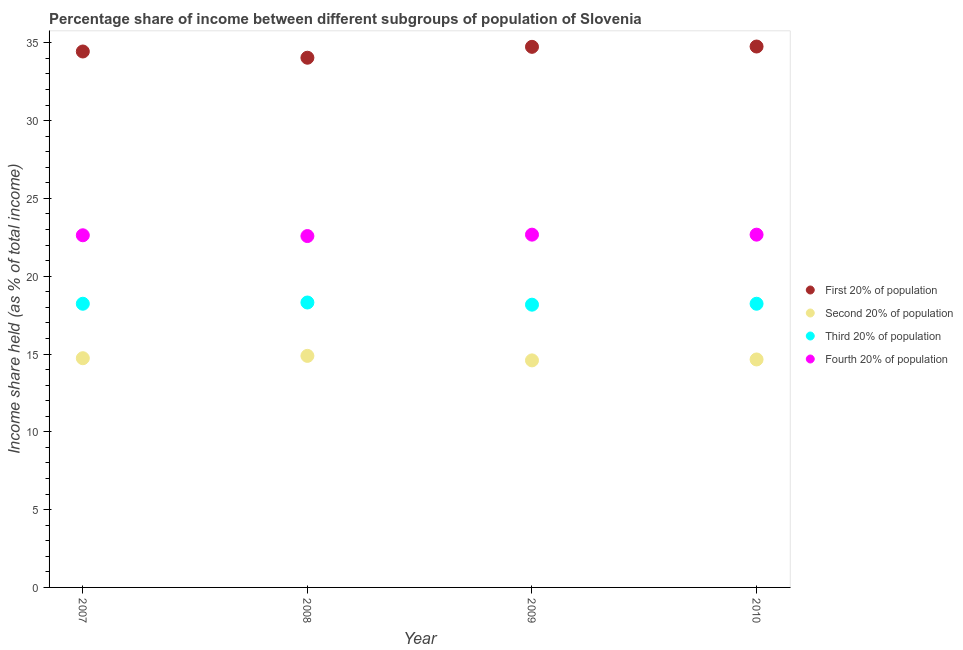What is the share of the income held by second 20% of the population in 2010?
Give a very brief answer. 14.65. Across all years, what is the maximum share of the income held by first 20% of the population?
Ensure brevity in your answer.  34.76. Across all years, what is the minimum share of the income held by fourth 20% of the population?
Ensure brevity in your answer.  22.58. In which year was the share of the income held by fourth 20% of the population maximum?
Provide a short and direct response. 2009. What is the total share of the income held by third 20% of the population in the graph?
Provide a short and direct response. 72.94. What is the difference between the share of the income held by third 20% of the population in 2007 and that in 2008?
Give a very brief answer. -0.08. What is the difference between the share of the income held by first 20% of the population in 2007 and the share of the income held by second 20% of the population in 2010?
Provide a short and direct response. 19.79. What is the average share of the income held by second 20% of the population per year?
Offer a terse response. 14.71. What is the ratio of the share of the income held by second 20% of the population in 2008 to that in 2010?
Keep it short and to the point. 1.02. Is the difference between the share of the income held by first 20% of the population in 2007 and 2010 greater than the difference between the share of the income held by fourth 20% of the population in 2007 and 2010?
Give a very brief answer. No. What is the difference between the highest and the second highest share of the income held by first 20% of the population?
Make the answer very short. 0.02. What is the difference between the highest and the lowest share of the income held by fourth 20% of the population?
Offer a terse response. 0.09. Is the sum of the share of the income held by third 20% of the population in 2009 and 2010 greater than the maximum share of the income held by fourth 20% of the population across all years?
Offer a terse response. Yes. Is it the case that in every year, the sum of the share of the income held by first 20% of the population and share of the income held by third 20% of the population is greater than the sum of share of the income held by fourth 20% of the population and share of the income held by second 20% of the population?
Your answer should be very brief. Yes. Is it the case that in every year, the sum of the share of the income held by first 20% of the population and share of the income held by second 20% of the population is greater than the share of the income held by third 20% of the population?
Provide a short and direct response. Yes. Is the share of the income held by third 20% of the population strictly greater than the share of the income held by first 20% of the population over the years?
Your answer should be very brief. No. Is the share of the income held by third 20% of the population strictly less than the share of the income held by fourth 20% of the population over the years?
Keep it short and to the point. Yes. How many years are there in the graph?
Provide a succinct answer. 4. What is the difference between two consecutive major ticks on the Y-axis?
Your answer should be very brief. 5. Are the values on the major ticks of Y-axis written in scientific E-notation?
Give a very brief answer. No. Does the graph contain any zero values?
Offer a very short reply. No. How many legend labels are there?
Your answer should be compact. 4. What is the title of the graph?
Provide a short and direct response. Percentage share of income between different subgroups of population of Slovenia. Does "Social Insurance" appear as one of the legend labels in the graph?
Keep it short and to the point. No. What is the label or title of the Y-axis?
Your answer should be very brief. Income share held (as % of total income). What is the Income share held (as % of total income) of First 20% of population in 2007?
Your response must be concise. 34.44. What is the Income share held (as % of total income) in Second 20% of population in 2007?
Your answer should be compact. 14.73. What is the Income share held (as % of total income) of Third 20% of population in 2007?
Ensure brevity in your answer.  18.23. What is the Income share held (as % of total income) in Fourth 20% of population in 2007?
Keep it short and to the point. 22.63. What is the Income share held (as % of total income) in First 20% of population in 2008?
Your answer should be compact. 34.04. What is the Income share held (as % of total income) of Second 20% of population in 2008?
Your answer should be compact. 14.88. What is the Income share held (as % of total income) of Third 20% of population in 2008?
Keep it short and to the point. 18.31. What is the Income share held (as % of total income) of Fourth 20% of population in 2008?
Offer a terse response. 22.58. What is the Income share held (as % of total income) of First 20% of population in 2009?
Your response must be concise. 34.74. What is the Income share held (as % of total income) in Second 20% of population in 2009?
Your response must be concise. 14.59. What is the Income share held (as % of total income) of Third 20% of population in 2009?
Make the answer very short. 18.17. What is the Income share held (as % of total income) of Fourth 20% of population in 2009?
Your answer should be compact. 22.67. What is the Income share held (as % of total income) of First 20% of population in 2010?
Ensure brevity in your answer.  34.76. What is the Income share held (as % of total income) in Second 20% of population in 2010?
Give a very brief answer. 14.65. What is the Income share held (as % of total income) in Third 20% of population in 2010?
Make the answer very short. 18.23. What is the Income share held (as % of total income) of Fourth 20% of population in 2010?
Offer a very short reply. 22.67. Across all years, what is the maximum Income share held (as % of total income) in First 20% of population?
Make the answer very short. 34.76. Across all years, what is the maximum Income share held (as % of total income) of Second 20% of population?
Offer a very short reply. 14.88. Across all years, what is the maximum Income share held (as % of total income) of Third 20% of population?
Ensure brevity in your answer.  18.31. Across all years, what is the maximum Income share held (as % of total income) in Fourth 20% of population?
Provide a short and direct response. 22.67. Across all years, what is the minimum Income share held (as % of total income) in First 20% of population?
Your answer should be very brief. 34.04. Across all years, what is the minimum Income share held (as % of total income) of Second 20% of population?
Ensure brevity in your answer.  14.59. Across all years, what is the minimum Income share held (as % of total income) of Third 20% of population?
Give a very brief answer. 18.17. Across all years, what is the minimum Income share held (as % of total income) of Fourth 20% of population?
Your answer should be compact. 22.58. What is the total Income share held (as % of total income) of First 20% of population in the graph?
Your answer should be very brief. 137.98. What is the total Income share held (as % of total income) in Second 20% of population in the graph?
Keep it short and to the point. 58.85. What is the total Income share held (as % of total income) in Third 20% of population in the graph?
Give a very brief answer. 72.94. What is the total Income share held (as % of total income) of Fourth 20% of population in the graph?
Offer a terse response. 90.55. What is the difference between the Income share held (as % of total income) in Third 20% of population in 2007 and that in 2008?
Offer a very short reply. -0.08. What is the difference between the Income share held (as % of total income) of Second 20% of population in 2007 and that in 2009?
Make the answer very short. 0.14. What is the difference between the Income share held (as % of total income) in Fourth 20% of population in 2007 and that in 2009?
Provide a succinct answer. -0.04. What is the difference between the Income share held (as % of total income) of First 20% of population in 2007 and that in 2010?
Ensure brevity in your answer.  -0.32. What is the difference between the Income share held (as % of total income) in Third 20% of population in 2007 and that in 2010?
Offer a terse response. 0. What is the difference between the Income share held (as % of total income) in Fourth 20% of population in 2007 and that in 2010?
Offer a very short reply. -0.04. What is the difference between the Income share held (as % of total income) in First 20% of population in 2008 and that in 2009?
Your response must be concise. -0.7. What is the difference between the Income share held (as % of total income) in Second 20% of population in 2008 and that in 2009?
Make the answer very short. 0.29. What is the difference between the Income share held (as % of total income) in Third 20% of population in 2008 and that in 2009?
Your answer should be very brief. 0.14. What is the difference between the Income share held (as % of total income) of Fourth 20% of population in 2008 and that in 2009?
Provide a succinct answer. -0.09. What is the difference between the Income share held (as % of total income) in First 20% of population in 2008 and that in 2010?
Offer a very short reply. -0.72. What is the difference between the Income share held (as % of total income) in Second 20% of population in 2008 and that in 2010?
Make the answer very short. 0.23. What is the difference between the Income share held (as % of total income) in Fourth 20% of population in 2008 and that in 2010?
Ensure brevity in your answer.  -0.09. What is the difference between the Income share held (as % of total income) in First 20% of population in 2009 and that in 2010?
Your response must be concise. -0.02. What is the difference between the Income share held (as % of total income) of Second 20% of population in 2009 and that in 2010?
Make the answer very short. -0.06. What is the difference between the Income share held (as % of total income) in Third 20% of population in 2009 and that in 2010?
Offer a terse response. -0.06. What is the difference between the Income share held (as % of total income) of First 20% of population in 2007 and the Income share held (as % of total income) of Second 20% of population in 2008?
Provide a succinct answer. 19.56. What is the difference between the Income share held (as % of total income) in First 20% of population in 2007 and the Income share held (as % of total income) in Third 20% of population in 2008?
Your response must be concise. 16.13. What is the difference between the Income share held (as % of total income) of First 20% of population in 2007 and the Income share held (as % of total income) of Fourth 20% of population in 2008?
Ensure brevity in your answer.  11.86. What is the difference between the Income share held (as % of total income) of Second 20% of population in 2007 and the Income share held (as % of total income) of Third 20% of population in 2008?
Offer a terse response. -3.58. What is the difference between the Income share held (as % of total income) of Second 20% of population in 2007 and the Income share held (as % of total income) of Fourth 20% of population in 2008?
Your answer should be very brief. -7.85. What is the difference between the Income share held (as % of total income) of Third 20% of population in 2007 and the Income share held (as % of total income) of Fourth 20% of population in 2008?
Offer a very short reply. -4.35. What is the difference between the Income share held (as % of total income) of First 20% of population in 2007 and the Income share held (as % of total income) of Second 20% of population in 2009?
Provide a succinct answer. 19.85. What is the difference between the Income share held (as % of total income) of First 20% of population in 2007 and the Income share held (as % of total income) of Third 20% of population in 2009?
Provide a short and direct response. 16.27. What is the difference between the Income share held (as % of total income) in First 20% of population in 2007 and the Income share held (as % of total income) in Fourth 20% of population in 2009?
Give a very brief answer. 11.77. What is the difference between the Income share held (as % of total income) of Second 20% of population in 2007 and the Income share held (as % of total income) of Third 20% of population in 2009?
Offer a terse response. -3.44. What is the difference between the Income share held (as % of total income) of Second 20% of population in 2007 and the Income share held (as % of total income) of Fourth 20% of population in 2009?
Ensure brevity in your answer.  -7.94. What is the difference between the Income share held (as % of total income) of Third 20% of population in 2007 and the Income share held (as % of total income) of Fourth 20% of population in 2009?
Make the answer very short. -4.44. What is the difference between the Income share held (as % of total income) in First 20% of population in 2007 and the Income share held (as % of total income) in Second 20% of population in 2010?
Your response must be concise. 19.79. What is the difference between the Income share held (as % of total income) in First 20% of population in 2007 and the Income share held (as % of total income) in Third 20% of population in 2010?
Your response must be concise. 16.21. What is the difference between the Income share held (as % of total income) in First 20% of population in 2007 and the Income share held (as % of total income) in Fourth 20% of population in 2010?
Keep it short and to the point. 11.77. What is the difference between the Income share held (as % of total income) of Second 20% of population in 2007 and the Income share held (as % of total income) of Third 20% of population in 2010?
Give a very brief answer. -3.5. What is the difference between the Income share held (as % of total income) in Second 20% of population in 2007 and the Income share held (as % of total income) in Fourth 20% of population in 2010?
Provide a short and direct response. -7.94. What is the difference between the Income share held (as % of total income) in Third 20% of population in 2007 and the Income share held (as % of total income) in Fourth 20% of population in 2010?
Provide a short and direct response. -4.44. What is the difference between the Income share held (as % of total income) in First 20% of population in 2008 and the Income share held (as % of total income) in Second 20% of population in 2009?
Your answer should be very brief. 19.45. What is the difference between the Income share held (as % of total income) in First 20% of population in 2008 and the Income share held (as % of total income) in Third 20% of population in 2009?
Provide a short and direct response. 15.87. What is the difference between the Income share held (as % of total income) of First 20% of population in 2008 and the Income share held (as % of total income) of Fourth 20% of population in 2009?
Ensure brevity in your answer.  11.37. What is the difference between the Income share held (as % of total income) of Second 20% of population in 2008 and the Income share held (as % of total income) of Third 20% of population in 2009?
Offer a very short reply. -3.29. What is the difference between the Income share held (as % of total income) of Second 20% of population in 2008 and the Income share held (as % of total income) of Fourth 20% of population in 2009?
Your response must be concise. -7.79. What is the difference between the Income share held (as % of total income) of Third 20% of population in 2008 and the Income share held (as % of total income) of Fourth 20% of population in 2009?
Your response must be concise. -4.36. What is the difference between the Income share held (as % of total income) of First 20% of population in 2008 and the Income share held (as % of total income) of Second 20% of population in 2010?
Offer a very short reply. 19.39. What is the difference between the Income share held (as % of total income) of First 20% of population in 2008 and the Income share held (as % of total income) of Third 20% of population in 2010?
Keep it short and to the point. 15.81. What is the difference between the Income share held (as % of total income) of First 20% of population in 2008 and the Income share held (as % of total income) of Fourth 20% of population in 2010?
Offer a terse response. 11.37. What is the difference between the Income share held (as % of total income) of Second 20% of population in 2008 and the Income share held (as % of total income) of Third 20% of population in 2010?
Keep it short and to the point. -3.35. What is the difference between the Income share held (as % of total income) in Second 20% of population in 2008 and the Income share held (as % of total income) in Fourth 20% of population in 2010?
Provide a succinct answer. -7.79. What is the difference between the Income share held (as % of total income) in Third 20% of population in 2008 and the Income share held (as % of total income) in Fourth 20% of population in 2010?
Offer a terse response. -4.36. What is the difference between the Income share held (as % of total income) of First 20% of population in 2009 and the Income share held (as % of total income) of Second 20% of population in 2010?
Your answer should be very brief. 20.09. What is the difference between the Income share held (as % of total income) of First 20% of population in 2009 and the Income share held (as % of total income) of Third 20% of population in 2010?
Your answer should be very brief. 16.51. What is the difference between the Income share held (as % of total income) in First 20% of population in 2009 and the Income share held (as % of total income) in Fourth 20% of population in 2010?
Give a very brief answer. 12.07. What is the difference between the Income share held (as % of total income) in Second 20% of population in 2009 and the Income share held (as % of total income) in Third 20% of population in 2010?
Provide a short and direct response. -3.64. What is the difference between the Income share held (as % of total income) in Second 20% of population in 2009 and the Income share held (as % of total income) in Fourth 20% of population in 2010?
Make the answer very short. -8.08. What is the average Income share held (as % of total income) of First 20% of population per year?
Your response must be concise. 34.49. What is the average Income share held (as % of total income) in Second 20% of population per year?
Your answer should be very brief. 14.71. What is the average Income share held (as % of total income) in Third 20% of population per year?
Ensure brevity in your answer.  18.23. What is the average Income share held (as % of total income) in Fourth 20% of population per year?
Ensure brevity in your answer.  22.64. In the year 2007, what is the difference between the Income share held (as % of total income) of First 20% of population and Income share held (as % of total income) of Second 20% of population?
Your response must be concise. 19.71. In the year 2007, what is the difference between the Income share held (as % of total income) of First 20% of population and Income share held (as % of total income) of Third 20% of population?
Your answer should be very brief. 16.21. In the year 2007, what is the difference between the Income share held (as % of total income) of First 20% of population and Income share held (as % of total income) of Fourth 20% of population?
Offer a very short reply. 11.81. In the year 2007, what is the difference between the Income share held (as % of total income) of Third 20% of population and Income share held (as % of total income) of Fourth 20% of population?
Offer a terse response. -4.4. In the year 2008, what is the difference between the Income share held (as % of total income) of First 20% of population and Income share held (as % of total income) of Second 20% of population?
Make the answer very short. 19.16. In the year 2008, what is the difference between the Income share held (as % of total income) of First 20% of population and Income share held (as % of total income) of Third 20% of population?
Your answer should be very brief. 15.73. In the year 2008, what is the difference between the Income share held (as % of total income) in First 20% of population and Income share held (as % of total income) in Fourth 20% of population?
Give a very brief answer. 11.46. In the year 2008, what is the difference between the Income share held (as % of total income) in Second 20% of population and Income share held (as % of total income) in Third 20% of population?
Your answer should be very brief. -3.43. In the year 2008, what is the difference between the Income share held (as % of total income) in Second 20% of population and Income share held (as % of total income) in Fourth 20% of population?
Your answer should be very brief. -7.7. In the year 2008, what is the difference between the Income share held (as % of total income) in Third 20% of population and Income share held (as % of total income) in Fourth 20% of population?
Make the answer very short. -4.27. In the year 2009, what is the difference between the Income share held (as % of total income) in First 20% of population and Income share held (as % of total income) in Second 20% of population?
Ensure brevity in your answer.  20.15. In the year 2009, what is the difference between the Income share held (as % of total income) of First 20% of population and Income share held (as % of total income) of Third 20% of population?
Offer a terse response. 16.57. In the year 2009, what is the difference between the Income share held (as % of total income) in First 20% of population and Income share held (as % of total income) in Fourth 20% of population?
Make the answer very short. 12.07. In the year 2009, what is the difference between the Income share held (as % of total income) in Second 20% of population and Income share held (as % of total income) in Third 20% of population?
Keep it short and to the point. -3.58. In the year 2009, what is the difference between the Income share held (as % of total income) of Second 20% of population and Income share held (as % of total income) of Fourth 20% of population?
Ensure brevity in your answer.  -8.08. In the year 2010, what is the difference between the Income share held (as % of total income) of First 20% of population and Income share held (as % of total income) of Second 20% of population?
Provide a short and direct response. 20.11. In the year 2010, what is the difference between the Income share held (as % of total income) in First 20% of population and Income share held (as % of total income) in Third 20% of population?
Offer a terse response. 16.53. In the year 2010, what is the difference between the Income share held (as % of total income) in First 20% of population and Income share held (as % of total income) in Fourth 20% of population?
Make the answer very short. 12.09. In the year 2010, what is the difference between the Income share held (as % of total income) in Second 20% of population and Income share held (as % of total income) in Third 20% of population?
Keep it short and to the point. -3.58. In the year 2010, what is the difference between the Income share held (as % of total income) in Second 20% of population and Income share held (as % of total income) in Fourth 20% of population?
Your response must be concise. -8.02. In the year 2010, what is the difference between the Income share held (as % of total income) of Third 20% of population and Income share held (as % of total income) of Fourth 20% of population?
Keep it short and to the point. -4.44. What is the ratio of the Income share held (as % of total income) of First 20% of population in 2007 to that in 2008?
Offer a very short reply. 1.01. What is the ratio of the Income share held (as % of total income) of Third 20% of population in 2007 to that in 2008?
Your answer should be compact. 1. What is the ratio of the Income share held (as % of total income) of Fourth 20% of population in 2007 to that in 2008?
Keep it short and to the point. 1. What is the ratio of the Income share held (as % of total income) in First 20% of population in 2007 to that in 2009?
Ensure brevity in your answer.  0.99. What is the ratio of the Income share held (as % of total income) in Second 20% of population in 2007 to that in 2009?
Provide a short and direct response. 1.01. What is the ratio of the Income share held (as % of total income) in First 20% of population in 2007 to that in 2010?
Keep it short and to the point. 0.99. What is the ratio of the Income share held (as % of total income) of Second 20% of population in 2007 to that in 2010?
Make the answer very short. 1.01. What is the ratio of the Income share held (as % of total income) in Third 20% of population in 2007 to that in 2010?
Offer a very short reply. 1. What is the ratio of the Income share held (as % of total income) in First 20% of population in 2008 to that in 2009?
Your answer should be very brief. 0.98. What is the ratio of the Income share held (as % of total income) in Second 20% of population in 2008 to that in 2009?
Offer a very short reply. 1.02. What is the ratio of the Income share held (as % of total income) in Third 20% of population in 2008 to that in 2009?
Provide a short and direct response. 1.01. What is the ratio of the Income share held (as % of total income) of First 20% of population in 2008 to that in 2010?
Offer a very short reply. 0.98. What is the ratio of the Income share held (as % of total income) of Second 20% of population in 2008 to that in 2010?
Provide a short and direct response. 1.02. What is the ratio of the Income share held (as % of total income) of Third 20% of population in 2009 to that in 2010?
Make the answer very short. 1. What is the ratio of the Income share held (as % of total income) in Fourth 20% of population in 2009 to that in 2010?
Make the answer very short. 1. What is the difference between the highest and the second highest Income share held (as % of total income) in Second 20% of population?
Ensure brevity in your answer.  0.15. What is the difference between the highest and the second highest Income share held (as % of total income) in Third 20% of population?
Provide a succinct answer. 0.08. What is the difference between the highest and the lowest Income share held (as % of total income) in First 20% of population?
Offer a very short reply. 0.72. What is the difference between the highest and the lowest Income share held (as % of total income) of Second 20% of population?
Give a very brief answer. 0.29. What is the difference between the highest and the lowest Income share held (as % of total income) in Third 20% of population?
Provide a succinct answer. 0.14. What is the difference between the highest and the lowest Income share held (as % of total income) in Fourth 20% of population?
Make the answer very short. 0.09. 